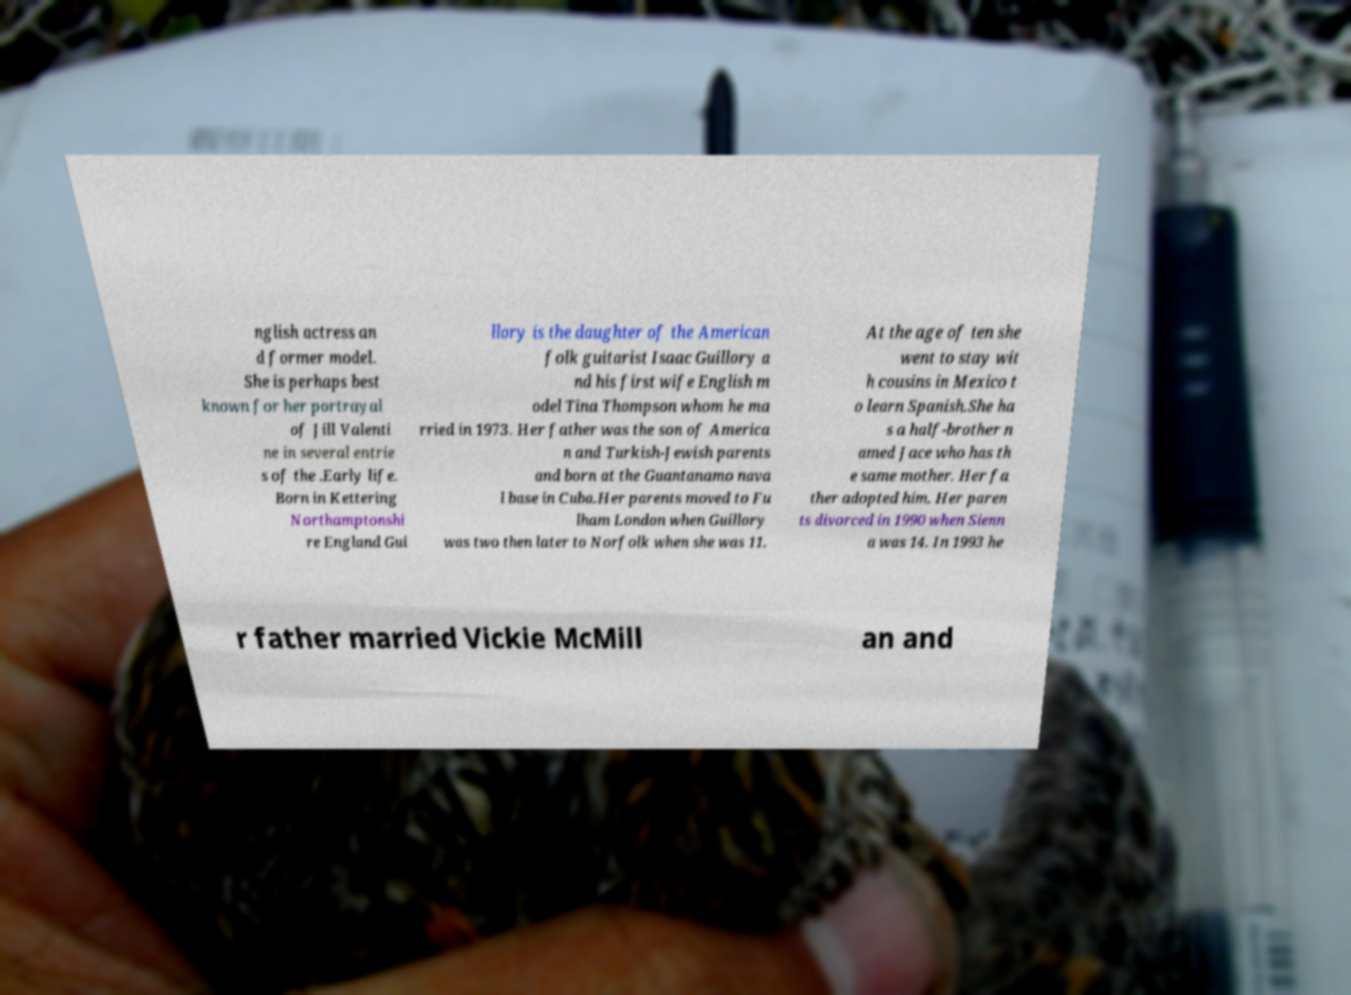What messages or text are displayed in this image? I need them in a readable, typed format. nglish actress an d former model. She is perhaps best known for her portrayal of Jill Valenti ne in several entrie s of the .Early life. Born in Kettering Northamptonshi re England Gui llory is the daughter of the American folk guitarist Isaac Guillory a nd his first wife English m odel Tina Thompson whom he ma rried in 1973. Her father was the son of America n and Turkish-Jewish parents and born at the Guantanamo nava l base in Cuba.Her parents moved to Fu lham London when Guillory was two then later to Norfolk when she was 11. At the age of ten she went to stay wit h cousins in Mexico t o learn Spanish.She ha s a half-brother n amed Jace who has th e same mother. Her fa ther adopted him. Her paren ts divorced in 1990 when Sienn a was 14. In 1993 he r father married Vickie McMill an and 